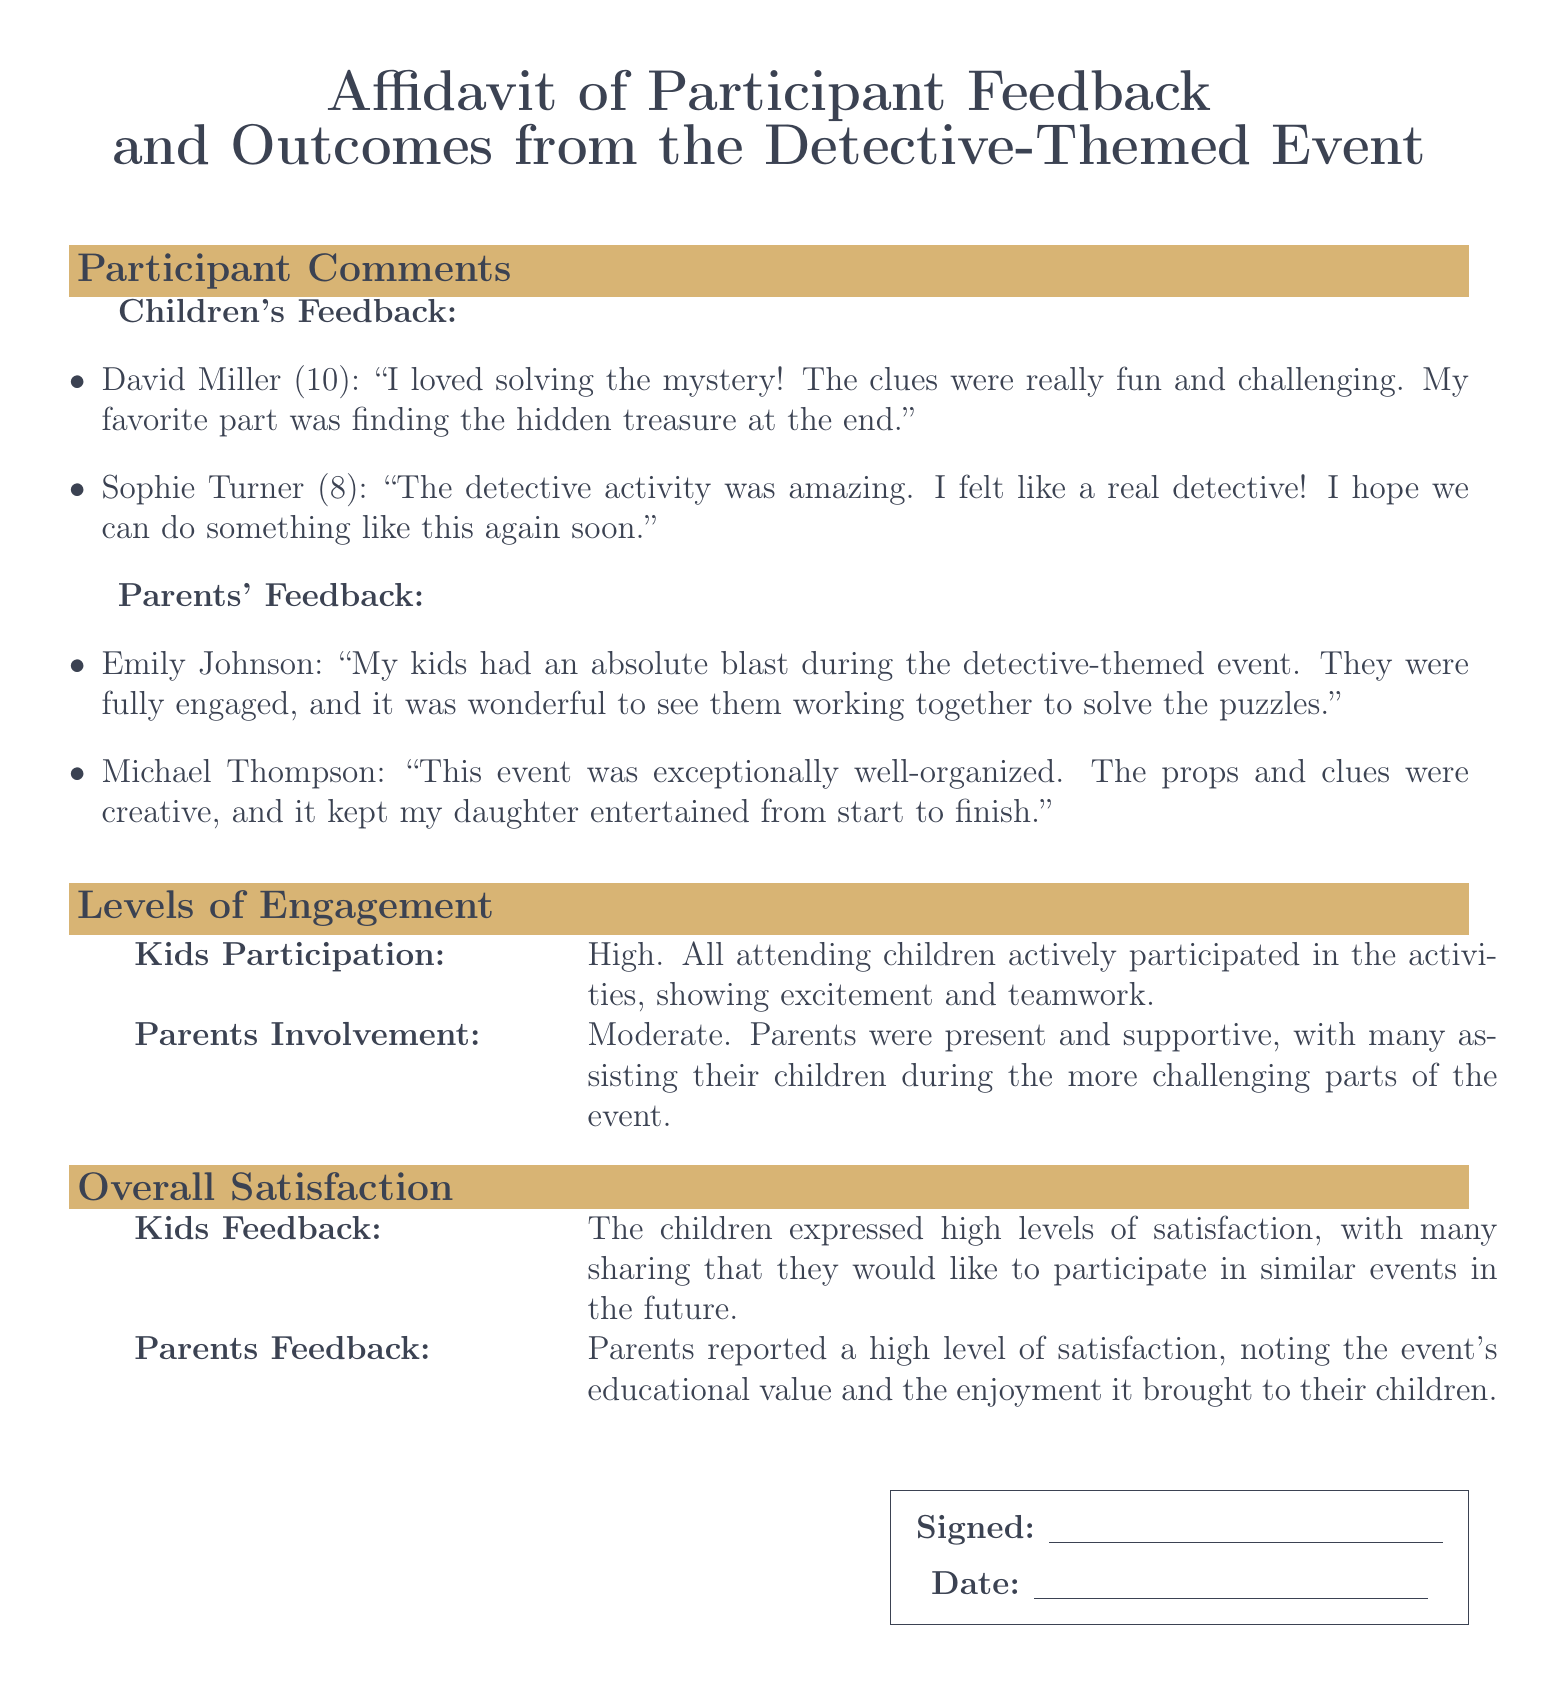What did David Miller love about the event? David Miller mentioned he loved solving the mystery and found the clues fun and challenging.
Answer: solving the mystery How old is Sophie Turner? The document states that Sophie Turner is 8 years old.
Answer: 8 Who provided feedback about the event? The feedback was given by both children and parents, as indicated in the document.
Answer: children and parents What was the level of kids' participation? The document states that the kids' participation was high during the activities.
Answer: High What did parents note about the event's educational value? Parents reported high satisfaction, highlighting the event's educational value and enjoyment.
Answer: educational value How many children expressed interest in similar events in the future? The document indicates that many children expressed interest in participating in similar events.
Answer: many Did parents assist during the event? The involvement of parents was moderate, with many assisting their children during challenges.
Answer: Yes What was the conclusion about parents' feedback on satisfaction? Parents reported a high level of satisfaction, noting enjoyment for their children.
Answer: high level of satisfaction 